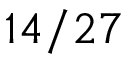Convert formula to latex. <formula><loc_0><loc_0><loc_500><loc_500>1 4 / 2 7</formula> 